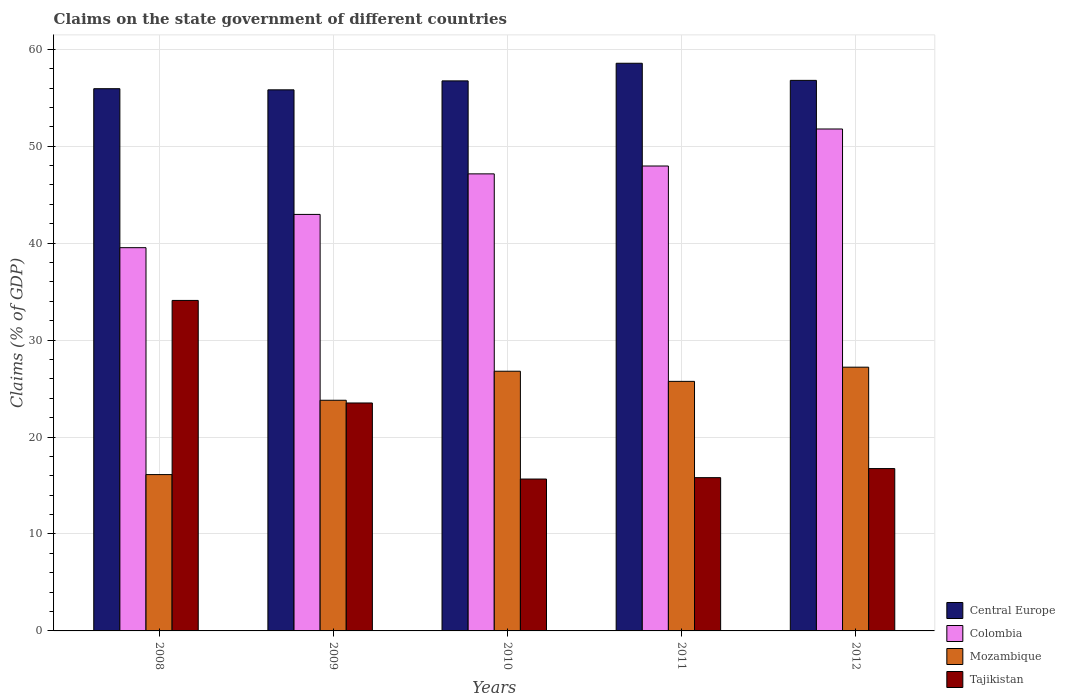How many different coloured bars are there?
Your response must be concise. 4. How many groups of bars are there?
Give a very brief answer. 5. Are the number of bars per tick equal to the number of legend labels?
Your answer should be compact. Yes. What is the label of the 2nd group of bars from the left?
Your response must be concise. 2009. What is the percentage of GDP claimed on the state government in Tajikistan in 2008?
Provide a succinct answer. 34.09. Across all years, what is the maximum percentage of GDP claimed on the state government in Tajikistan?
Give a very brief answer. 34.09. Across all years, what is the minimum percentage of GDP claimed on the state government in Tajikistan?
Offer a terse response. 15.67. In which year was the percentage of GDP claimed on the state government in Tajikistan maximum?
Your answer should be compact. 2008. What is the total percentage of GDP claimed on the state government in Colombia in the graph?
Your answer should be compact. 229.36. What is the difference between the percentage of GDP claimed on the state government in Colombia in 2008 and that in 2011?
Your response must be concise. -8.42. What is the difference between the percentage of GDP claimed on the state government in Colombia in 2008 and the percentage of GDP claimed on the state government in Mozambique in 2010?
Provide a succinct answer. 12.74. What is the average percentage of GDP claimed on the state government in Colombia per year?
Provide a short and direct response. 45.87. In the year 2011, what is the difference between the percentage of GDP claimed on the state government in Mozambique and percentage of GDP claimed on the state government in Tajikistan?
Ensure brevity in your answer.  9.93. In how many years, is the percentage of GDP claimed on the state government in Colombia greater than 8 %?
Your answer should be very brief. 5. What is the ratio of the percentage of GDP claimed on the state government in Mozambique in 2008 to that in 2009?
Your response must be concise. 0.68. What is the difference between the highest and the second highest percentage of GDP claimed on the state government in Central Europe?
Provide a succinct answer. 1.76. What is the difference between the highest and the lowest percentage of GDP claimed on the state government in Colombia?
Provide a succinct answer. 12.24. In how many years, is the percentage of GDP claimed on the state government in Tajikistan greater than the average percentage of GDP claimed on the state government in Tajikistan taken over all years?
Your answer should be compact. 2. Is the sum of the percentage of GDP claimed on the state government in Tajikistan in 2009 and 2012 greater than the maximum percentage of GDP claimed on the state government in Mozambique across all years?
Make the answer very short. Yes. What does the 3rd bar from the left in 2010 represents?
Provide a succinct answer. Mozambique. What does the 2nd bar from the right in 2010 represents?
Give a very brief answer. Mozambique. How many years are there in the graph?
Your answer should be very brief. 5. Are the values on the major ticks of Y-axis written in scientific E-notation?
Your response must be concise. No. Does the graph contain any zero values?
Offer a very short reply. No. Where does the legend appear in the graph?
Keep it short and to the point. Bottom right. How many legend labels are there?
Your answer should be compact. 4. What is the title of the graph?
Your answer should be very brief. Claims on the state government of different countries. Does "OECD members" appear as one of the legend labels in the graph?
Provide a succinct answer. No. What is the label or title of the Y-axis?
Keep it short and to the point. Claims (% of GDP). What is the Claims (% of GDP) of Central Europe in 2008?
Your answer should be compact. 55.93. What is the Claims (% of GDP) in Colombia in 2008?
Your answer should be very brief. 39.53. What is the Claims (% of GDP) in Mozambique in 2008?
Your answer should be very brief. 16.13. What is the Claims (% of GDP) in Tajikistan in 2008?
Your response must be concise. 34.09. What is the Claims (% of GDP) in Central Europe in 2009?
Provide a short and direct response. 55.81. What is the Claims (% of GDP) in Colombia in 2009?
Offer a very short reply. 42.96. What is the Claims (% of GDP) in Mozambique in 2009?
Ensure brevity in your answer.  23.79. What is the Claims (% of GDP) of Tajikistan in 2009?
Keep it short and to the point. 23.51. What is the Claims (% of GDP) in Central Europe in 2010?
Provide a short and direct response. 56.73. What is the Claims (% of GDP) in Colombia in 2010?
Offer a very short reply. 47.14. What is the Claims (% of GDP) in Mozambique in 2010?
Your answer should be compact. 26.79. What is the Claims (% of GDP) of Tajikistan in 2010?
Provide a succinct answer. 15.67. What is the Claims (% of GDP) of Central Europe in 2011?
Provide a short and direct response. 58.55. What is the Claims (% of GDP) in Colombia in 2011?
Make the answer very short. 47.96. What is the Claims (% of GDP) in Mozambique in 2011?
Make the answer very short. 25.74. What is the Claims (% of GDP) in Tajikistan in 2011?
Give a very brief answer. 15.81. What is the Claims (% of GDP) of Central Europe in 2012?
Keep it short and to the point. 56.79. What is the Claims (% of GDP) in Colombia in 2012?
Provide a succinct answer. 51.77. What is the Claims (% of GDP) of Mozambique in 2012?
Ensure brevity in your answer.  27.2. What is the Claims (% of GDP) of Tajikistan in 2012?
Offer a terse response. 16.75. Across all years, what is the maximum Claims (% of GDP) of Central Europe?
Provide a short and direct response. 58.55. Across all years, what is the maximum Claims (% of GDP) in Colombia?
Offer a very short reply. 51.77. Across all years, what is the maximum Claims (% of GDP) in Mozambique?
Provide a short and direct response. 27.2. Across all years, what is the maximum Claims (% of GDP) of Tajikistan?
Make the answer very short. 34.09. Across all years, what is the minimum Claims (% of GDP) of Central Europe?
Ensure brevity in your answer.  55.81. Across all years, what is the minimum Claims (% of GDP) of Colombia?
Your response must be concise. 39.53. Across all years, what is the minimum Claims (% of GDP) of Mozambique?
Make the answer very short. 16.13. Across all years, what is the minimum Claims (% of GDP) in Tajikistan?
Give a very brief answer. 15.67. What is the total Claims (% of GDP) in Central Europe in the graph?
Make the answer very short. 283.82. What is the total Claims (% of GDP) in Colombia in the graph?
Your answer should be compact. 229.36. What is the total Claims (% of GDP) in Mozambique in the graph?
Give a very brief answer. 119.65. What is the total Claims (% of GDP) in Tajikistan in the graph?
Offer a terse response. 105.82. What is the difference between the Claims (% of GDP) of Central Europe in 2008 and that in 2009?
Offer a very short reply. 0.12. What is the difference between the Claims (% of GDP) of Colombia in 2008 and that in 2009?
Give a very brief answer. -3.43. What is the difference between the Claims (% of GDP) in Mozambique in 2008 and that in 2009?
Offer a very short reply. -7.67. What is the difference between the Claims (% of GDP) of Tajikistan in 2008 and that in 2009?
Provide a succinct answer. 10.58. What is the difference between the Claims (% of GDP) in Central Europe in 2008 and that in 2010?
Give a very brief answer. -0.81. What is the difference between the Claims (% of GDP) of Colombia in 2008 and that in 2010?
Ensure brevity in your answer.  -7.61. What is the difference between the Claims (% of GDP) in Mozambique in 2008 and that in 2010?
Make the answer very short. -10.66. What is the difference between the Claims (% of GDP) in Tajikistan in 2008 and that in 2010?
Offer a very short reply. 18.42. What is the difference between the Claims (% of GDP) in Central Europe in 2008 and that in 2011?
Your response must be concise. -2.62. What is the difference between the Claims (% of GDP) of Colombia in 2008 and that in 2011?
Offer a terse response. -8.42. What is the difference between the Claims (% of GDP) in Mozambique in 2008 and that in 2011?
Offer a very short reply. -9.62. What is the difference between the Claims (% of GDP) of Tajikistan in 2008 and that in 2011?
Ensure brevity in your answer.  18.28. What is the difference between the Claims (% of GDP) in Central Europe in 2008 and that in 2012?
Your answer should be compact. -0.86. What is the difference between the Claims (% of GDP) of Colombia in 2008 and that in 2012?
Ensure brevity in your answer.  -12.24. What is the difference between the Claims (% of GDP) of Mozambique in 2008 and that in 2012?
Provide a succinct answer. -11.08. What is the difference between the Claims (% of GDP) of Tajikistan in 2008 and that in 2012?
Keep it short and to the point. 17.34. What is the difference between the Claims (% of GDP) in Central Europe in 2009 and that in 2010?
Provide a succinct answer. -0.92. What is the difference between the Claims (% of GDP) in Colombia in 2009 and that in 2010?
Keep it short and to the point. -4.18. What is the difference between the Claims (% of GDP) in Mozambique in 2009 and that in 2010?
Offer a very short reply. -2.99. What is the difference between the Claims (% of GDP) of Tajikistan in 2009 and that in 2010?
Provide a succinct answer. 7.85. What is the difference between the Claims (% of GDP) in Central Europe in 2009 and that in 2011?
Provide a succinct answer. -2.74. What is the difference between the Claims (% of GDP) of Colombia in 2009 and that in 2011?
Give a very brief answer. -4.99. What is the difference between the Claims (% of GDP) in Mozambique in 2009 and that in 2011?
Ensure brevity in your answer.  -1.95. What is the difference between the Claims (% of GDP) of Tajikistan in 2009 and that in 2011?
Give a very brief answer. 7.7. What is the difference between the Claims (% of GDP) of Central Europe in 2009 and that in 2012?
Offer a terse response. -0.98. What is the difference between the Claims (% of GDP) in Colombia in 2009 and that in 2012?
Provide a succinct answer. -8.81. What is the difference between the Claims (% of GDP) in Mozambique in 2009 and that in 2012?
Your response must be concise. -3.41. What is the difference between the Claims (% of GDP) of Tajikistan in 2009 and that in 2012?
Your answer should be very brief. 6.77. What is the difference between the Claims (% of GDP) in Central Europe in 2010 and that in 2011?
Offer a very short reply. -1.82. What is the difference between the Claims (% of GDP) in Colombia in 2010 and that in 2011?
Offer a very short reply. -0.81. What is the difference between the Claims (% of GDP) of Mozambique in 2010 and that in 2011?
Ensure brevity in your answer.  1.05. What is the difference between the Claims (% of GDP) in Tajikistan in 2010 and that in 2011?
Ensure brevity in your answer.  -0.14. What is the difference between the Claims (% of GDP) of Central Europe in 2010 and that in 2012?
Give a very brief answer. -0.05. What is the difference between the Claims (% of GDP) of Colombia in 2010 and that in 2012?
Give a very brief answer. -4.63. What is the difference between the Claims (% of GDP) of Mozambique in 2010 and that in 2012?
Your response must be concise. -0.42. What is the difference between the Claims (% of GDP) in Tajikistan in 2010 and that in 2012?
Keep it short and to the point. -1.08. What is the difference between the Claims (% of GDP) of Central Europe in 2011 and that in 2012?
Your answer should be very brief. 1.76. What is the difference between the Claims (% of GDP) in Colombia in 2011 and that in 2012?
Your response must be concise. -3.82. What is the difference between the Claims (% of GDP) in Mozambique in 2011 and that in 2012?
Offer a terse response. -1.46. What is the difference between the Claims (% of GDP) in Tajikistan in 2011 and that in 2012?
Offer a very short reply. -0.94. What is the difference between the Claims (% of GDP) of Central Europe in 2008 and the Claims (% of GDP) of Colombia in 2009?
Keep it short and to the point. 12.97. What is the difference between the Claims (% of GDP) of Central Europe in 2008 and the Claims (% of GDP) of Mozambique in 2009?
Make the answer very short. 32.14. What is the difference between the Claims (% of GDP) in Central Europe in 2008 and the Claims (% of GDP) in Tajikistan in 2009?
Provide a succinct answer. 32.42. What is the difference between the Claims (% of GDP) of Colombia in 2008 and the Claims (% of GDP) of Mozambique in 2009?
Provide a short and direct response. 15.74. What is the difference between the Claims (% of GDP) in Colombia in 2008 and the Claims (% of GDP) in Tajikistan in 2009?
Make the answer very short. 16.02. What is the difference between the Claims (% of GDP) of Mozambique in 2008 and the Claims (% of GDP) of Tajikistan in 2009?
Make the answer very short. -7.39. What is the difference between the Claims (% of GDP) in Central Europe in 2008 and the Claims (% of GDP) in Colombia in 2010?
Keep it short and to the point. 8.79. What is the difference between the Claims (% of GDP) in Central Europe in 2008 and the Claims (% of GDP) in Mozambique in 2010?
Give a very brief answer. 29.14. What is the difference between the Claims (% of GDP) in Central Europe in 2008 and the Claims (% of GDP) in Tajikistan in 2010?
Make the answer very short. 40.26. What is the difference between the Claims (% of GDP) in Colombia in 2008 and the Claims (% of GDP) in Mozambique in 2010?
Keep it short and to the point. 12.74. What is the difference between the Claims (% of GDP) in Colombia in 2008 and the Claims (% of GDP) in Tajikistan in 2010?
Offer a very short reply. 23.86. What is the difference between the Claims (% of GDP) in Mozambique in 2008 and the Claims (% of GDP) in Tajikistan in 2010?
Your answer should be compact. 0.46. What is the difference between the Claims (% of GDP) of Central Europe in 2008 and the Claims (% of GDP) of Colombia in 2011?
Provide a succinct answer. 7.97. What is the difference between the Claims (% of GDP) of Central Europe in 2008 and the Claims (% of GDP) of Mozambique in 2011?
Offer a very short reply. 30.19. What is the difference between the Claims (% of GDP) in Central Europe in 2008 and the Claims (% of GDP) in Tajikistan in 2011?
Make the answer very short. 40.12. What is the difference between the Claims (% of GDP) of Colombia in 2008 and the Claims (% of GDP) of Mozambique in 2011?
Provide a short and direct response. 13.79. What is the difference between the Claims (% of GDP) in Colombia in 2008 and the Claims (% of GDP) in Tajikistan in 2011?
Ensure brevity in your answer.  23.72. What is the difference between the Claims (% of GDP) in Mozambique in 2008 and the Claims (% of GDP) in Tajikistan in 2011?
Provide a succinct answer. 0.32. What is the difference between the Claims (% of GDP) of Central Europe in 2008 and the Claims (% of GDP) of Colombia in 2012?
Provide a short and direct response. 4.16. What is the difference between the Claims (% of GDP) in Central Europe in 2008 and the Claims (% of GDP) in Mozambique in 2012?
Your response must be concise. 28.72. What is the difference between the Claims (% of GDP) in Central Europe in 2008 and the Claims (% of GDP) in Tajikistan in 2012?
Make the answer very short. 39.18. What is the difference between the Claims (% of GDP) in Colombia in 2008 and the Claims (% of GDP) in Mozambique in 2012?
Offer a terse response. 12.33. What is the difference between the Claims (% of GDP) of Colombia in 2008 and the Claims (% of GDP) of Tajikistan in 2012?
Your response must be concise. 22.78. What is the difference between the Claims (% of GDP) in Mozambique in 2008 and the Claims (% of GDP) in Tajikistan in 2012?
Your response must be concise. -0.62. What is the difference between the Claims (% of GDP) of Central Europe in 2009 and the Claims (% of GDP) of Colombia in 2010?
Provide a short and direct response. 8.67. What is the difference between the Claims (% of GDP) of Central Europe in 2009 and the Claims (% of GDP) of Mozambique in 2010?
Make the answer very short. 29.02. What is the difference between the Claims (% of GDP) in Central Europe in 2009 and the Claims (% of GDP) in Tajikistan in 2010?
Make the answer very short. 40.14. What is the difference between the Claims (% of GDP) in Colombia in 2009 and the Claims (% of GDP) in Mozambique in 2010?
Offer a very short reply. 16.17. What is the difference between the Claims (% of GDP) of Colombia in 2009 and the Claims (% of GDP) of Tajikistan in 2010?
Ensure brevity in your answer.  27.3. What is the difference between the Claims (% of GDP) in Mozambique in 2009 and the Claims (% of GDP) in Tajikistan in 2010?
Your answer should be compact. 8.13. What is the difference between the Claims (% of GDP) of Central Europe in 2009 and the Claims (% of GDP) of Colombia in 2011?
Give a very brief answer. 7.86. What is the difference between the Claims (% of GDP) of Central Europe in 2009 and the Claims (% of GDP) of Mozambique in 2011?
Give a very brief answer. 30.07. What is the difference between the Claims (% of GDP) in Central Europe in 2009 and the Claims (% of GDP) in Tajikistan in 2011?
Offer a very short reply. 40. What is the difference between the Claims (% of GDP) of Colombia in 2009 and the Claims (% of GDP) of Mozambique in 2011?
Keep it short and to the point. 17.22. What is the difference between the Claims (% of GDP) in Colombia in 2009 and the Claims (% of GDP) in Tajikistan in 2011?
Offer a terse response. 27.15. What is the difference between the Claims (% of GDP) of Mozambique in 2009 and the Claims (% of GDP) of Tajikistan in 2011?
Provide a short and direct response. 7.98. What is the difference between the Claims (% of GDP) of Central Europe in 2009 and the Claims (% of GDP) of Colombia in 2012?
Ensure brevity in your answer.  4.04. What is the difference between the Claims (% of GDP) of Central Europe in 2009 and the Claims (% of GDP) of Mozambique in 2012?
Provide a short and direct response. 28.61. What is the difference between the Claims (% of GDP) in Central Europe in 2009 and the Claims (% of GDP) in Tajikistan in 2012?
Make the answer very short. 39.06. What is the difference between the Claims (% of GDP) in Colombia in 2009 and the Claims (% of GDP) in Mozambique in 2012?
Give a very brief answer. 15.76. What is the difference between the Claims (% of GDP) of Colombia in 2009 and the Claims (% of GDP) of Tajikistan in 2012?
Provide a succinct answer. 26.22. What is the difference between the Claims (% of GDP) of Mozambique in 2009 and the Claims (% of GDP) of Tajikistan in 2012?
Provide a succinct answer. 7.05. What is the difference between the Claims (% of GDP) of Central Europe in 2010 and the Claims (% of GDP) of Colombia in 2011?
Your answer should be compact. 8.78. What is the difference between the Claims (% of GDP) of Central Europe in 2010 and the Claims (% of GDP) of Mozambique in 2011?
Make the answer very short. 30.99. What is the difference between the Claims (% of GDP) of Central Europe in 2010 and the Claims (% of GDP) of Tajikistan in 2011?
Offer a very short reply. 40.93. What is the difference between the Claims (% of GDP) of Colombia in 2010 and the Claims (% of GDP) of Mozambique in 2011?
Offer a very short reply. 21.4. What is the difference between the Claims (% of GDP) of Colombia in 2010 and the Claims (% of GDP) of Tajikistan in 2011?
Give a very brief answer. 31.34. What is the difference between the Claims (% of GDP) of Mozambique in 2010 and the Claims (% of GDP) of Tajikistan in 2011?
Your answer should be very brief. 10.98. What is the difference between the Claims (% of GDP) in Central Europe in 2010 and the Claims (% of GDP) in Colombia in 2012?
Ensure brevity in your answer.  4.96. What is the difference between the Claims (% of GDP) in Central Europe in 2010 and the Claims (% of GDP) in Mozambique in 2012?
Give a very brief answer. 29.53. What is the difference between the Claims (% of GDP) in Central Europe in 2010 and the Claims (% of GDP) in Tajikistan in 2012?
Your response must be concise. 39.99. What is the difference between the Claims (% of GDP) in Colombia in 2010 and the Claims (% of GDP) in Mozambique in 2012?
Your answer should be very brief. 19.94. What is the difference between the Claims (% of GDP) of Colombia in 2010 and the Claims (% of GDP) of Tajikistan in 2012?
Ensure brevity in your answer.  30.4. What is the difference between the Claims (% of GDP) of Mozambique in 2010 and the Claims (% of GDP) of Tajikistan in 2012?
Ensure brevity in your answer.  10.04. What is the difference between the Claims (% of GDP) in Central Europe in 2011 and the Claims (% of GDP) in Colombia in 2012?
Offer a very short reply. 6.78. What is the difference between the Claims (% of GDP) of Central Europe in 2011 and the Claims (% of GDP) of Mozambique in 2012?
Your answer should be compact. 31.35. What is the difference between the Claims (% of GDP) of Central Europe in 2011 and the Claims (% of GDP) of Tajikistan in 2012?
Your answer should be very brief. 41.81. What is the difference between the Claims (% of GDP) of Colombia in 2011 and the Claims (% of GDP) of Mozambique in 2012?
Your answer should be very brief. 20.75. What is the difference between the Claims (% of GDP) in Colombia in 2011 and the Claims (% of GDP) in Tajikistan in 2012?
Your response must be concise. 31.21. What is the difference between the Claims (% of GDP) of Mozambique in 2011 and the Claims (% of GDP) of Tajikistan in 2012?
Offer a very short reply. 8.99. What is the average Claims (% of GDP) of Central Europe per year?
Provide a succinct answer. 56.76. What is the average Claims (% of GDP) of Colombia per year?
Your answer should be compact. 45.87. What is the average Claims (% of GDP) in Mozambique per year?
Your answer should be compact. 23.93. What is the average Claims (% of GDP) in Tajikistan per year?
Provide a short and direct response. 21.16. In the year 2008, what is the difference between the Claims (% of GDP) in Central Europe and Claims (% of GDP) in Colombia?
Keep it short and to the point. 16.4. In the year 2008, what is the difference between the Claims (% of GDP) of Central Europe and Claims (% of GDP) of Mozambique?
Your answer should be compact. 39.8. In the year 2008, what is the difference between the Claims (% of GDP) of Central Europe and Claims (% of GDP) of Tajikistan?
Your answer should be compact. 21.84. In the year 2008, what is the difference between the Claims (% of GDP) in Colombia and Claims (% of GDP) in Mozambique?
Your answer should be compact. 23.41. In the year 2008, what is the difference between the Claims (% of GDP) of Colombia and Claims (% of GDP) of Tajikistan?
Offer a very short reply. 5.44. In the year 2008, what is the difference between the Claims (% of GDP) in Mozambique and Claims (% of GDP) in Tajikistan?
Provide a short and direct response. -17.96. In the year 2009, what is the difference between the Claims (% of GDP) of Central Europe and Claims (% of GDP) of Colombia?
Provide a short and direct response. 12.85. In the year 2009, what is the difference between the Claims (% of GDP) of Central Europe and Claims (% of GDP) of Mozambique?
Provide a succinct answer. 32.02. In the year 2009, what is the difference between the Claims (% of GDP) in Central Europe and Claims (% of GDP) in Tajikistan?
Make the answer very short. 32.3. In the year 2009, what is the difference between the Claims (% of GDP) in Colombia and Claims (% of GDP) in Mozambique?
Provide a succinct answer. 19.17. In the year 2009, what is the difference between the Claims (% of GDP) of Colombia and Claims (% of GDP) of Tajikistan?
Ensure brevity in your answer.  19.45. In the year 2009, what is the difference between the Claims (% of GDP) in Mozambique and Claims (% of GDP) in Tajikistan?
Provide a short and direct response. 0.28. In the year 2010, what is the difference between the Claims (% of GDP) of Central Europe and Claims (% of GDP) of Colombia?
Your answer should be very brief. 9.59. In the year 2010, what is the difference between the Claims (% of GDP) in Central Europe and Claims (% of GDP) in Mozambique?
Ensure brevity in your answer.  29.95. In the year 2010, what is the difference between the Claims (% of GDP) of Central Europe and Claims (% of GDP) of Tajikistan?
Offer a terse response. 41.07. In the year 2010, what is the difference between the Claims (% of GDP) in Colombia and Claims (% of GDP) in Mozambique?
Make the answer very short. 20.36. In the year 2010, what is the difference between the Claims (% of GDP) of Colombia and Claims (% of GDP) of Tajikistan?
Provide a short and direct response. 31.48. In the year 2010, what is the difference between the Claims (% of GDP) of Mozambique and Claims (% of GDP) of Tajikistan?
Offer a very short reply. 11.12. In the year 2011, what is the difference between the Claims (% of GDP) of Central Europe and Claims (% of GDP) of Colombia?
Ensure brevity in your answer.  10.6. In the year 2011, what is the difference between the Claims (% of GDP) in Central Europe and Claims (% of GDP) in Mozambique?
Make the answer very short. 32.81. In the year 2011, what is the difference between the Claims (% of GDP) in Central Europe and Claims (% of GDP) in Tajikistan?
Keep it short and to the point. 42.74. In the year 2011, what is the difference between the Claims (% of GDP) in Colombia and Claims (% of GDP) in Mozambique?
Your response must be concise. 22.21. In the year 2011, what is the difference between the Claims (% of GDP) of Colombia and Claims (% of GDP) of Tajikistan?
Your response must be concise. 32.15. In the year 2011, what is the difference between the Claims (% of GDP) of Mozambique and Claims (% of GDP) of Tajikistan?
Make the answer very short. 9.93. In the year 2012, what is the difference between the Claims (% of GDP) in Central Europe and Claims (% of GDP) in Colombia?
Your answer should be compact. 5.02. In the year 2012, what is the difference between the Claims (% of GDP) in Central Europe and Claims (% of GDP) in Mozambique?
Make the answer very short. 29.58. In the year 2012, what is the difference between the Claims (% of GDP) of Central Europe and Claims (% of GDP) of Tajikistan?
Make the answer very short. 40.04. In the year 2012, what is the difference between the Claims (% of GDP) in Colombia and Claims (% of GDP) in Mozambique?
Make the answer very short. 24.57. In the year 2012, what is the difference between the Claims (% of GDP) in Colombia and Claims (% of GDP) in Tajikistan?
Your response must be concise. 35.03. In the year 2012, what is the difference between the Claims (% of GDP) of Mozambique and Claims (% of GDP) of Tajikistan?
Offer a very short reply. 10.46. What is the ratio of the Claims (% of GDP) of Central Europe in 2008 to that in 2009?
Your answer should be very brief. 1. What is the ratio of the Claims (% of GDP) of Colombia in 2008 to that in 2009?
Your response must be concise. 0.92. What is the ratio of the Claims (% of GDP) of Mozambique in 2008 to that in 2009?
Your response must be concise. 0.68. What is the ratio of the Claims (% of GDP) in Tajikistan in 2008 to that in 2009?
Give a very brief answer. 1.45. What is the ratio of the Claims (% of GDP) of Central Europe in 2008 to that in 2010?
Ensure brevity in your answer.  0.99. What is the ratio of the Claims (% of GDP) in Colombia in 2008 to that in 2010?
Offer a very short reply. 0.84. What is the ratio of the Claims (% of GDP) of Mozambique in 2008 to that in 2010?
Give a very brief answer. 0.6. What is the ratio of the Claims (% of GDP) in Tajikistan in 2008 to that in 2010?
Offer a terse response. 2.18. What is the ratio of the Claims (% of GDP) of Central Europe in 2008 to that in 2011?
Offer a terse response. 0.96. What is the ratio of the Claims (% of GDP) in Colombia in 2008 to that in 2011?
Ensure brevity in your answer.  0.82. What is the ratio of the Claims (% of GDP) of Mozambique in 2008 to that in 2011?
Provide a succinct answer. 0.63. What is the ratio of the Claims (% of GDP) in Tajikistan in 2008 to that in 2011?
Keep it short and to the point. 2.16. What is the ratio of the Claims (% of GDP) in Central Europe in 2008 to that in 2012?
Keep it short and to the point. 0.98. What is the ratio of the Claims (% of GDP) in Colombia in 2008 to that in 2012?
Your answer should be compact. 0.76. What is the ratio of the Claims (% of GDP) in Mozambique in 2008 to that in 2012?
Ensure brevity in your answer.  0.59. What is the ratio of the Claims (% of GDP) in Tajikistan in 2008 to that in 2012?
Offer a terse response. 2.04. What is the ratio of the Claims (% of GDP) in Central Europe in 2009 to that in 2010?
Make the answer very short. 0.98. What is the ratio of the Claims (% of GDP) of Colombia in 2009 to that in 2010?
Your response must be concise. 0.91. What is the ratio of the Claims (% of GDP) of Mozambique in 2009 to that in 2010?
Give a very brief answer. 0.89. What is the ratio of the Claims (% of GDP) of Tajikistan in 2009 to that in 2010?
Ensure brevity in your answer.  1.5. What is the ratio of the Claims (% of GDP) of Central Europe in 2009 to that in 2011?
Your answer should be compact. 0.95. What is the ratio of the Claims (% of GDP) of Colombia in 2009 to that in 2011?
Give a very brief answer. 0.9. What is the ratio of the Claims (% of GDP) of Mozambique in 2009 to that in 2011?
Make the answer very short. 0.92. What is the ratio of the Claims (% of GDP) in Tajikistan in 2009 to that in 2011?
Your answer should be compact. 1.49. What is the ratio of the Claims (% of GDP) in Central Europe in 2009 to that in 2012?
Ensure brevity in your answer.  0.98. What is the ratio of the Claims (% of GDP) in Colombia in 2009 to that in 2012?
Ensure brevity in your answer.  0.83. What is the ratio of the Claims (% of GDP) in Mozambique in 2009 to that in 2012?
Keep it short and to the point. 0.87. What is the ratio of the Claims (% of GDP) in Tajikistan in 2009 to that in 2012?
Your answer should be compact. 1.4. What is the ratio of the Claims (% of GDP) in Colombia in 2010 to that in 2011?
Your response must be concise. 0.98. What is the ratio of the Claims (% of GDP) in Mozambique in 2010 to that in 2011?
Give a very brief answer. 1.04. What is the ratio of the Claims (% of GDP) in Colombia in 2010 to that in 2012?
Your answer should be very brief. 0.91. What is the ratio of the Claims (% of GDP) of Mozambique in 2010 to that in 2012?
Make the answer very short. 0.98. What is the ratio of the Claims (% of GDP) of Tajikistan in 2010 to that in 2012?
Provide a succinct answer. 0.94. What is the ratio of the Claims (% of GDP) of Central Europe in 2011 to that in 2012?
Offer a very short reply. 1.03. What is the ratio of the Claims (% of GDP) of Colombia in 2011 to that in 2012?
Ensure brevity in your answer.  0.93. What is the ratio of the Claims (% of GDP) of Mozambique in 2011 to that in 2012?
Give a very brief answer. 0.95. What is the ratio of the Claims (% of GDP) in Tajikistan in 2011 to that in 2012?
Your response must be concise. 0.94. What is the difference between the highest and the second highest Claims (% of GDP) of Central Europe?
Make the answer very short. 1.76. What is the difference between the highest and the second highest Claims (% of GDP) of Colombia?
Offer a very short reply. 3.82. What is the difference between the highest and the second highest Claims (% of GDP) in Mozambique?
Your response must be concise. 0.42. What is the difference between the highest and the second highest Claims (% of GDP) of Tajikistan?
Make the answer very short. 10.58. What is the difference between the highest and the lowest Claims (% of GDP) in Central Europe?
Give a very brief answer. 2.74. What is the difference between the highest and the lowest Claims (% of GDP) in Colombia?
Make the answer very short. 12.24. What is the difference between the highest and the lowest Claims (% of GDP) in Mozambique?
Make the answer very short. 11.08. What is the difference between the highest and the lowest Claims (% of GDP) of Tajikistan?
Offer a very short reply. 18.42. 